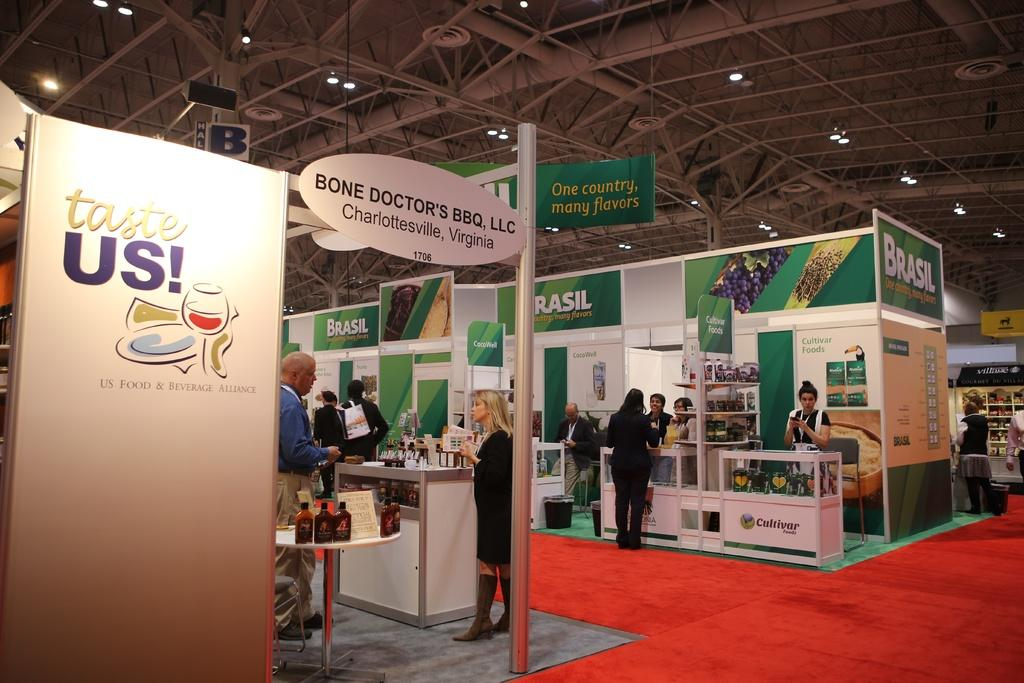<image>
Describe the image concisely. A convention booth for the Bone Doctor's BBQ in Charlottesville, Virginia. 